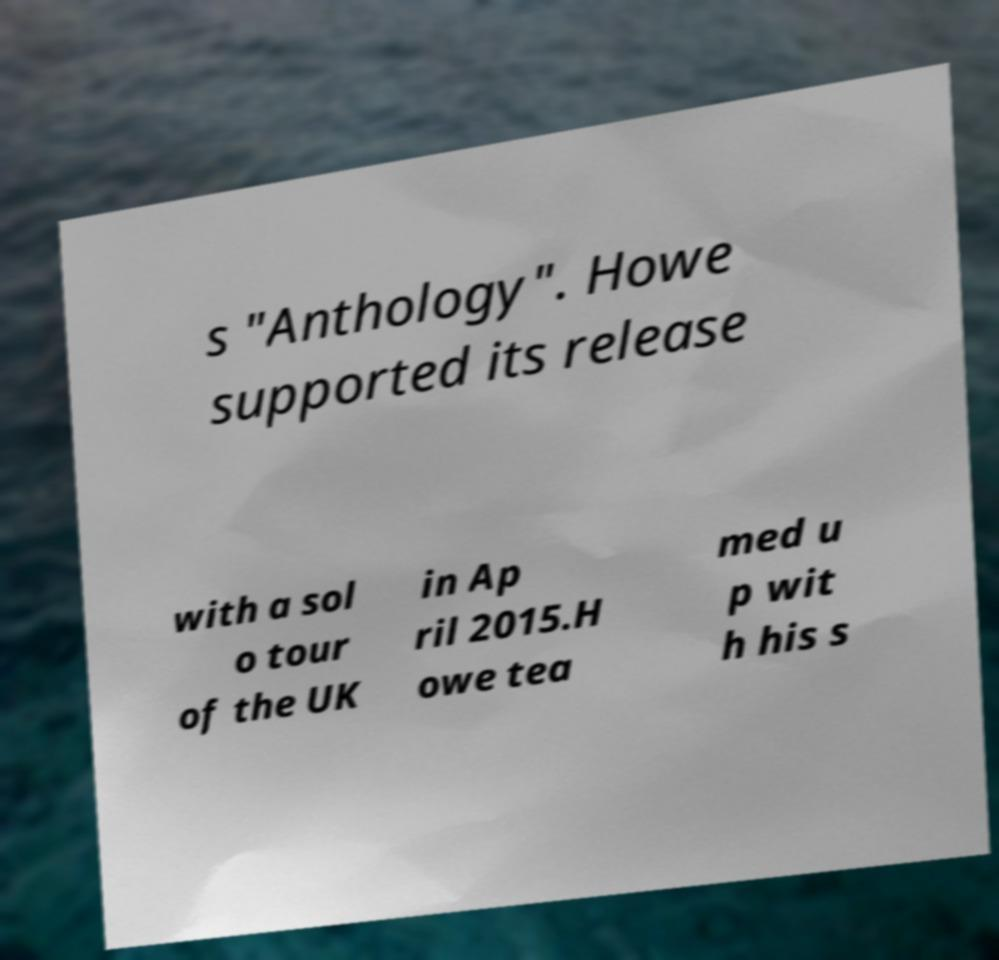Please identify and transcribe the text found in this image. s "Anthology". Howe supported its release with a sol o tour of the UK in Ap ril 2015.H owe tea med u p wit h his s 